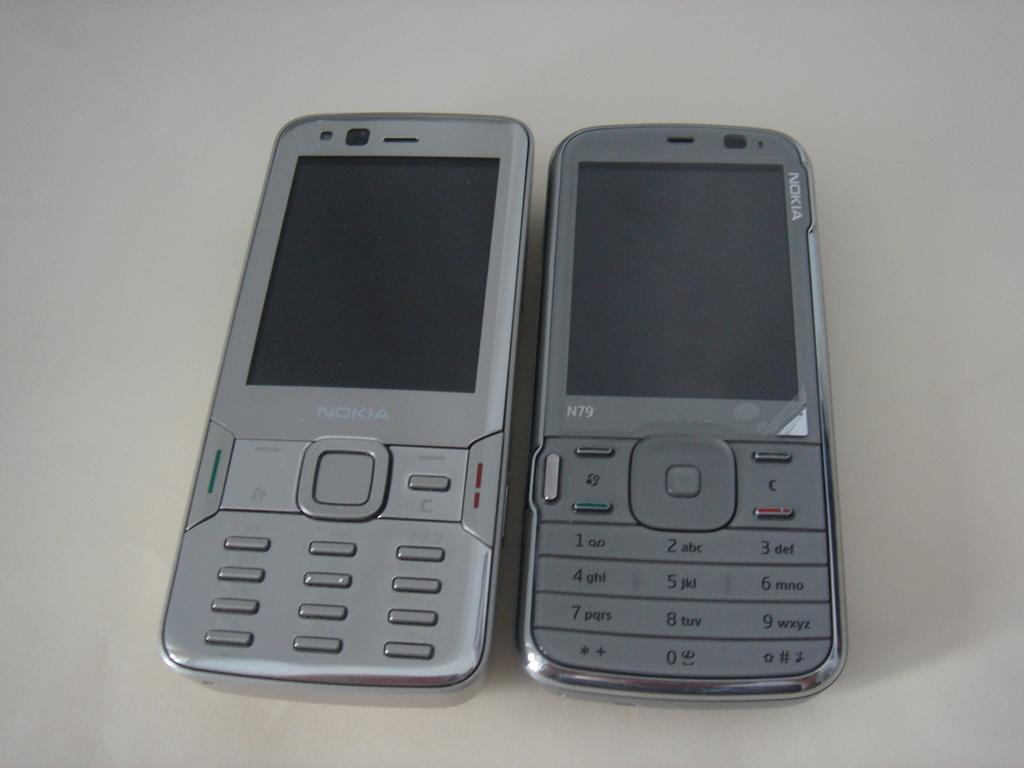<image>
Create a compact narrative representing the image presented. Light grey Nokia next to a darker colored Nokia phone modeled N79. 